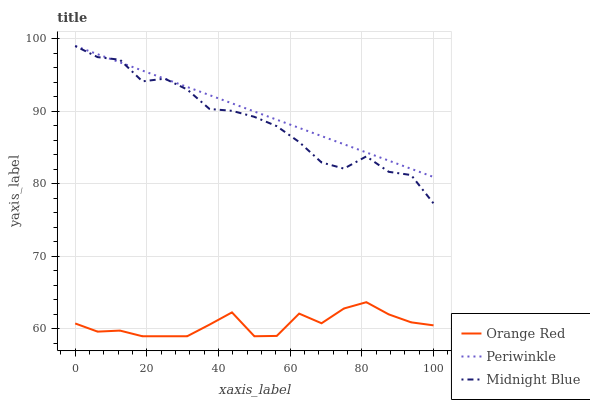Does Orange Red have the minimum area under the curve?
Answer yes or no. Yes. Does Periwinkle have the maximum area under the curve?
Answer yes or no. Yes. Does Midnight Blue have the minimum area under the curve?
Answer yes or no. No. Does Midnight Blue have the maximum area under the curve?
Answer yes or no. No. Is Periwinkle the smoothest?
Answer yes or no. Yes. Is Orange Red the roughest?
Answer yes or no. Yes. Is Midnight Blue the smoothest?
Answer yes or no. No. Is Midnight Blue the roughest?
Answer yes or no. No. Does Orange Red have the lowest value?
Answer yes or no. Yes. Does Midnight Blue have the lowest value?
Answer yes or no. No. Does Midnight Blue have the highest value?
Answer yes or no. Yes. Does Orange Red have the highest value?
Answer yes or no. No. Is Orange Red less than Periwinkle?
Answer yes or no. Yes. Is Midnight Blue greater than Orange Red?
Answer yes or no. Yes. Does Midnight Blue intersect Periwinkle?
Answer yes or no. Yes. Is Midnight Blue less than Periwinkle?
Answer yes or no. No. Is Midnight Blue greater than Periwinkle?
Answer yes or no. No. Does Orange Red intersect Periwinkle?
Answer yes or no. No. 